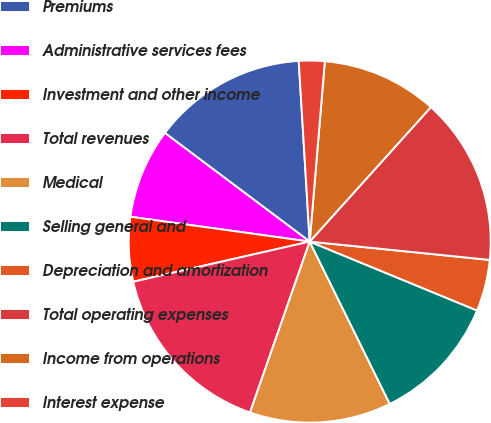<chart> <loc_0><loc_0><loc_500><loc_500><pie_chart><fcel>Premiums<fcel>Administrative services fees<fcel>Investment and other income<fcel>Total revenues<fcel>Medical<fcel>Selling general and<fcel>Depreciation and amortization<fcel>Total operating expenses<fcel>Income from operations<fcel>Interest expense<nl><fcel>13.79%<fcel>8.05%<fcel>5.75%<fcel>16.09%<fcel>12.64%<fcel>11.49%<fcel>4.6%<fcel>14.94%<fcel>10.34%<fcel>2.3%<nl></chart> 